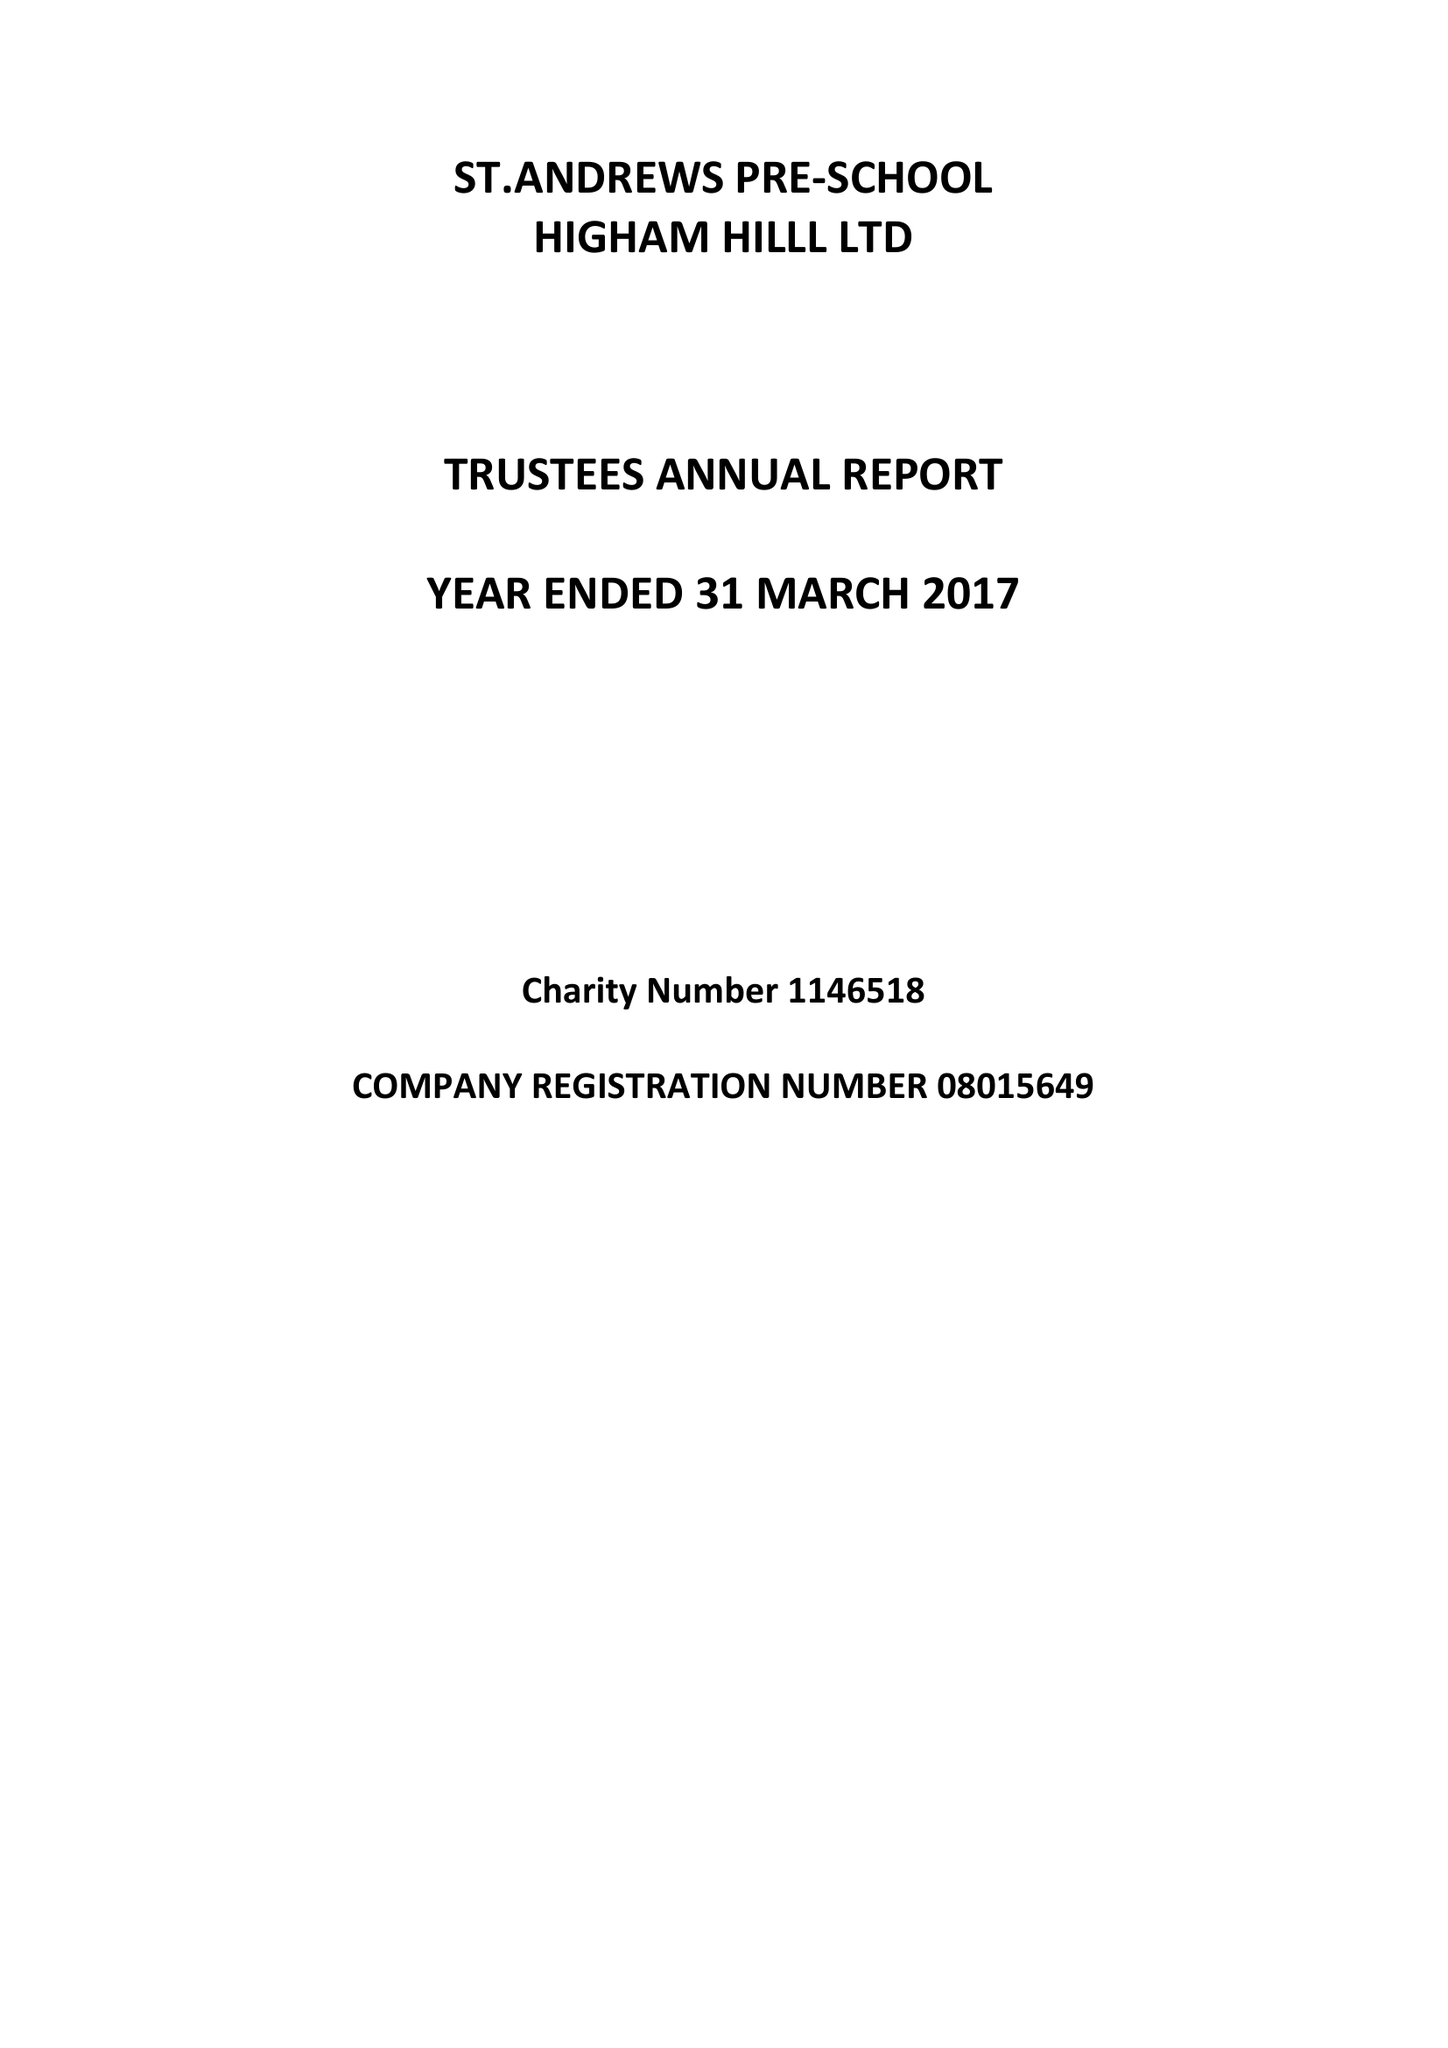What is the value for the charity_name?
Answer the question using a single word or phrase. St.Andrews Pre-School Higham Hill Ltd. 